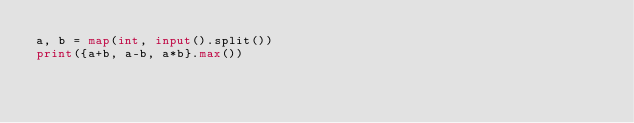<code> <loc_0><loc_0><loc_500><loc_500><_Python_>a, b = map(int, input().split())
print({a+b, a-b, a*b}.max())</code> 